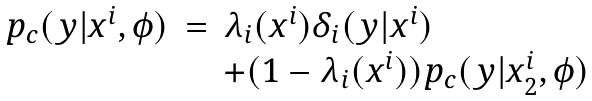<formula> <loc_0><loc_0><loc_500><loc_500>\begin{array} { c l l } p _ { c } ( y | x ^ { i } , \phi ) & = & \lambda _ { i } ( x ^ { i } ) \delta _ { i } ( y | x ^ { i } ) \\ & & + ( 1 - \lambda _ { i } ( x ^ { i } ) ) p _ { c } ( y | x _ { 2 } ^ { i } , \phi ) \end{array}</formula> 